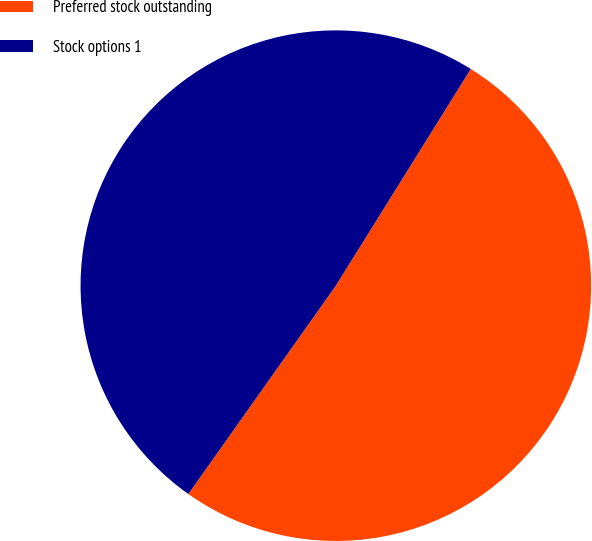<chart> <loc_0><loc_0><loc_500><loc_500><pie_chart><fcel>Preferred stock outstanding<fcel>Stock options 1<nl><fcel>50.94%<fcel>49.06%<nl></chart> 